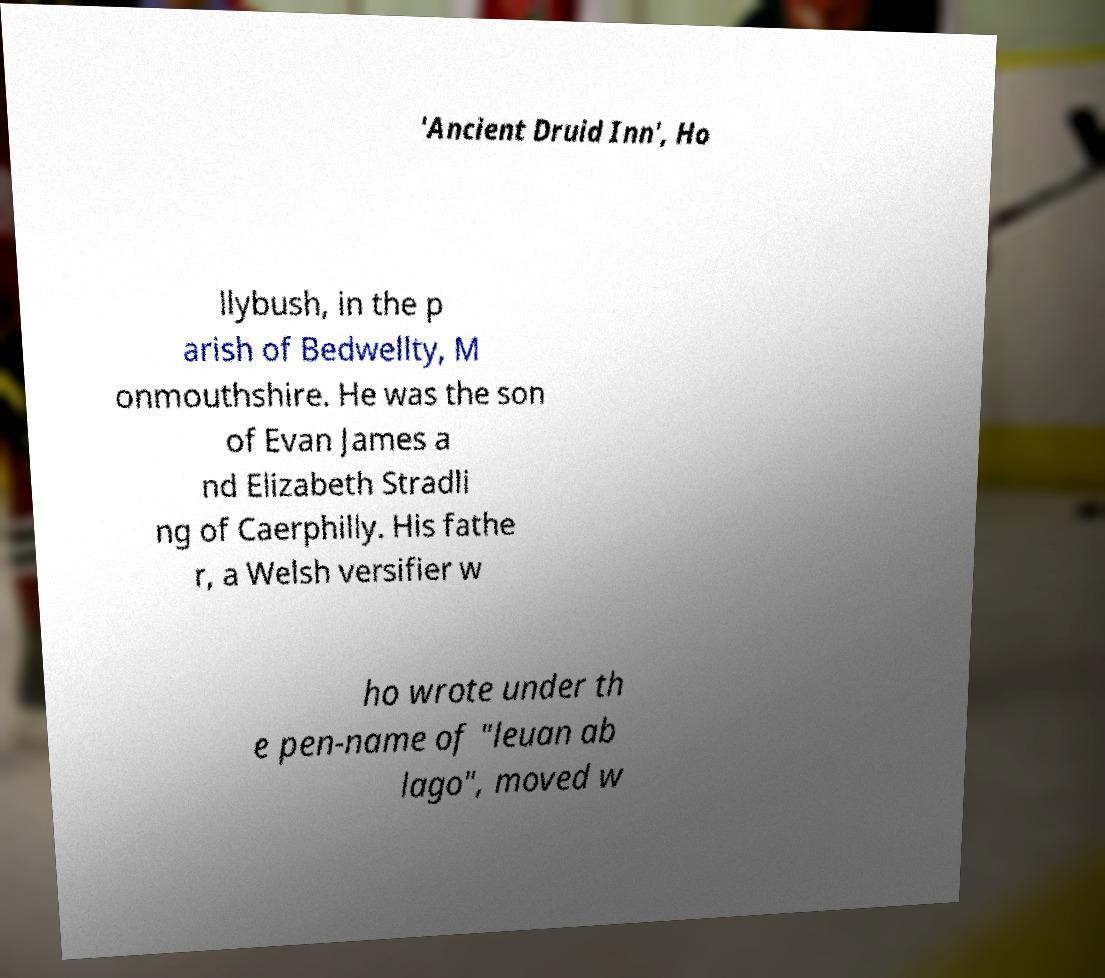Can you read and provide the text displayed in the image?This photo seems to have some interesting text. Can you extract and type it out for me? 'Ancient Druid Inn', Ho llybush, in the p arish of Bedwellty, M onmouthshire. He was the son of Evan James a nd Elizabeth Stradli ng of Caerphilly. His fathe r, a Welsh versifier w ho wrote under th e pen-name of "leuan ab lago", moved w 